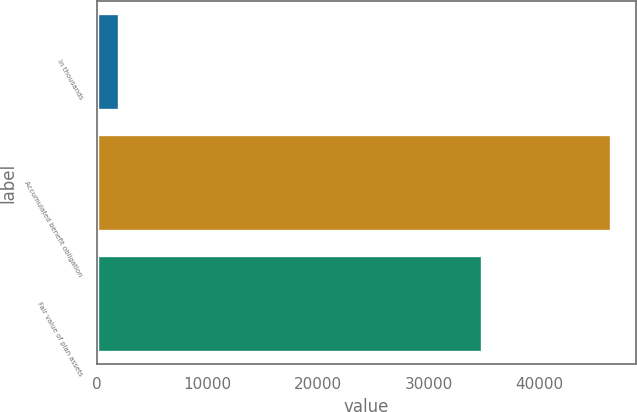Convert chart. <chart><loc_0><loc_0><loc_500><loc_500><bar_chart><fcel>In thousands<fcel>Accumulated benefit obligation<fcel>Fair value of plan assets<nl><fcel>2009<fcel>46472<fcel>34872<nl></chart> 